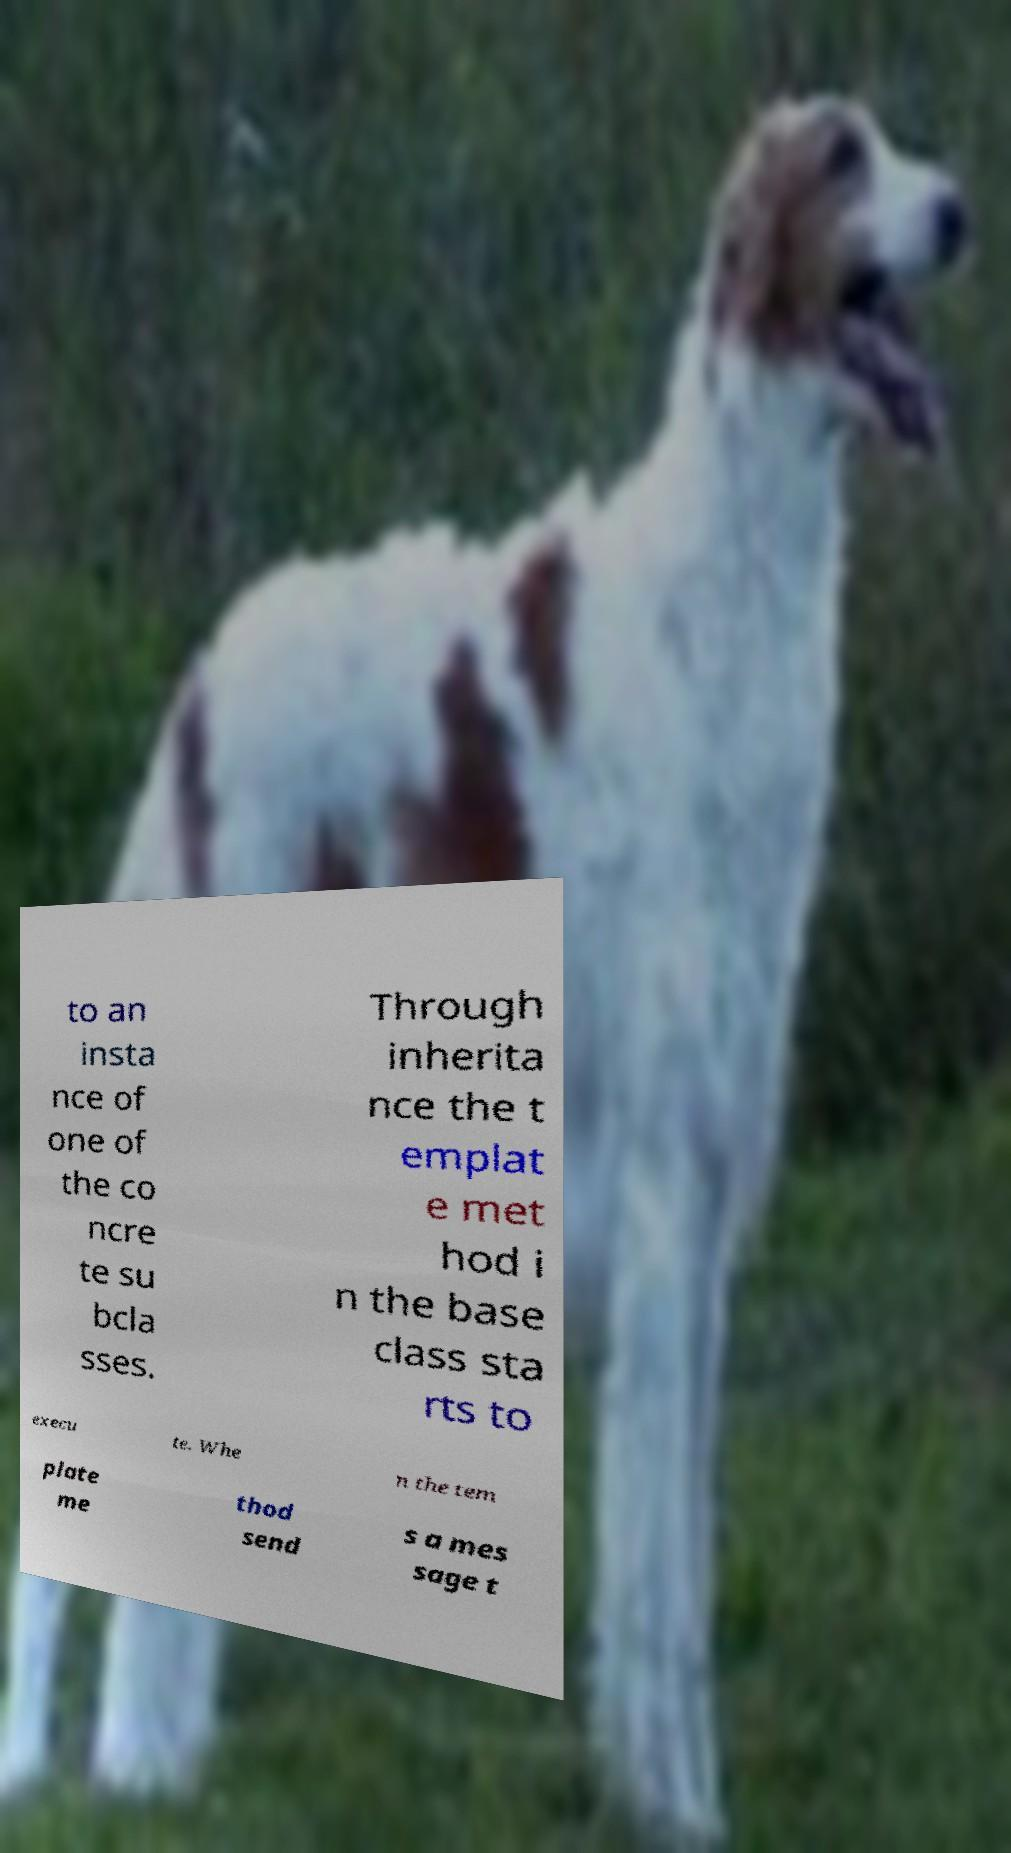For documentation purposes, I need the text within this image transcribed. Could you provide that? to an insta nce of one of the co ncre te su bcla sses. Through inherita nce the t emplat e met hod i n the base class sta rts to execu te. Whe n the tem plate me thod send s a mes sage t 